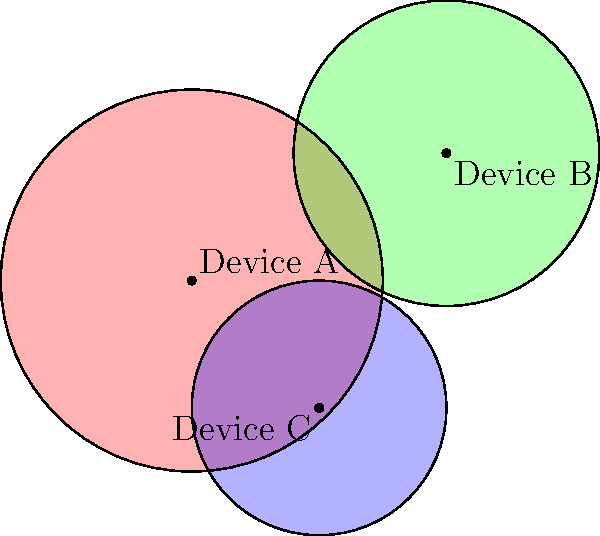In the diagram above, three smart home devices (A, B, and C) are represented by circles showing their signal ranges. Which area represents the zone where all three devices' signals potentially interfere with each other? To identify the area where all three devices' signals potentially interfere, we need to follow these steps:

1. Understand that each circle represents the signal range of a smart home device.
2. Device A is represented by the red circle.
3. Device B is represented by the green circle.
4. Device C is represented by the blue circle.
5. The area of interference for all three devices would be where all three circles overlap.
6. Visually inspect the diagram to find the region where all three colors (red, green, and blue) are present.
7. This overlapping area appears as a darker, more saturated region in the center of the diagram.
8. This central area is relatively small compared to the individual circles, indicating a limited zone of potential interference for all three devices.

The area where all three circles overlap represents the zone where signals from Devices A, B, and C could potentially interfere with each other. This is the region we're looking for in the question.
Answer: The central overlapping region of all three circles 